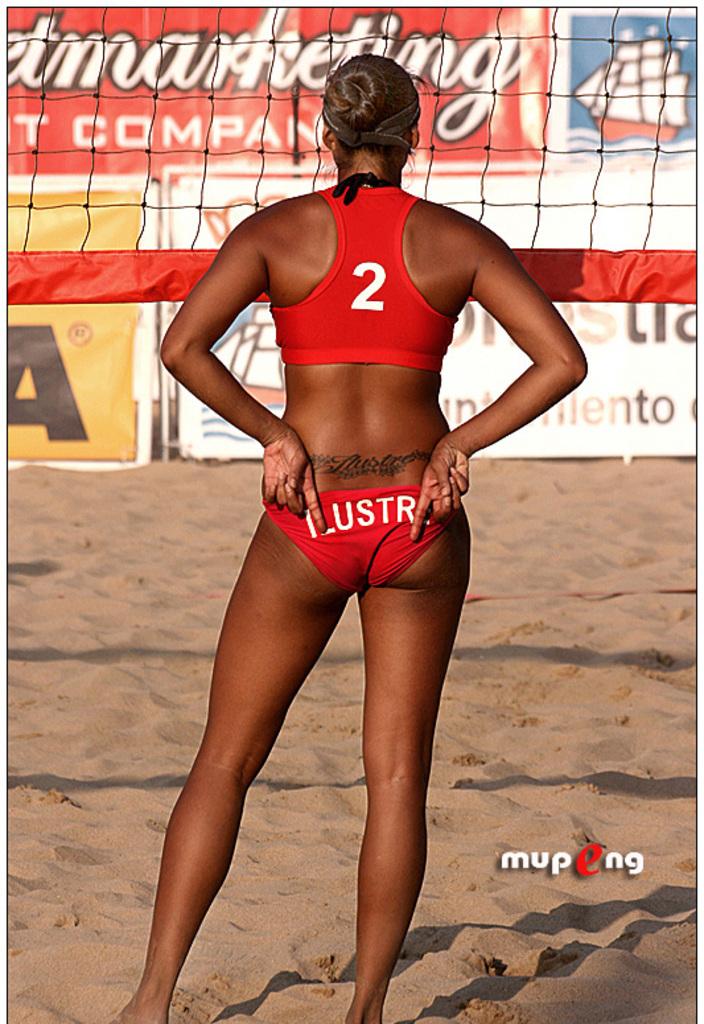What number is on the back of the top?
Your response must be concise. 2. What is written on her pants?
Provide a succinct answer. Ustr. 